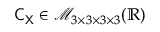<formula> <loc_0><loc_0><loc_500><loc_500>C _ { X } \in \mathcal { M } _ { 3 \times 3 \times 3 \times 3 } ( \mathbb { R } )</formula> 